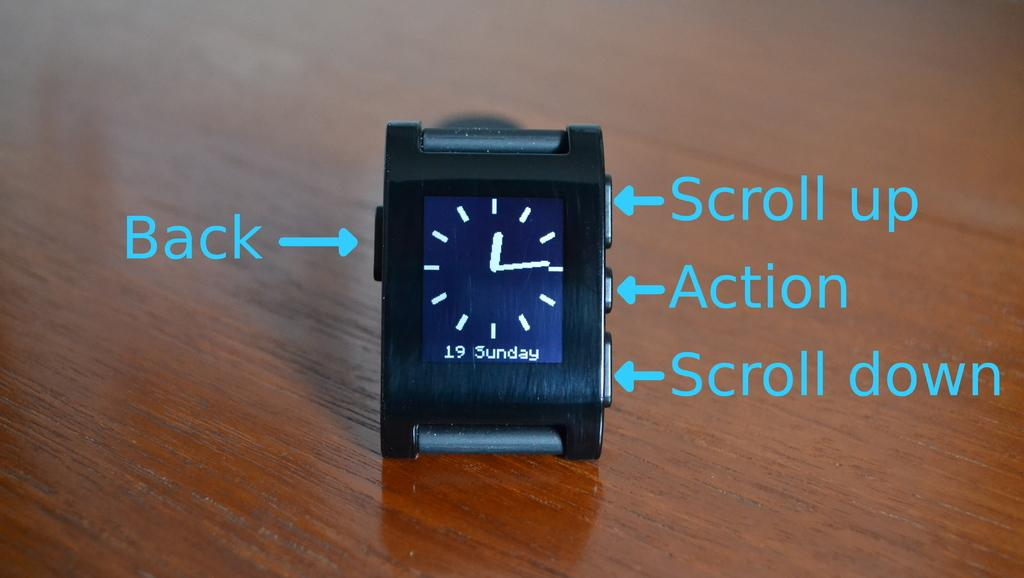Provide a one-sentence caption for the provided image. A tiny clock with instructions to scroll up, scroll down, action and Back written on the side of the picture. 